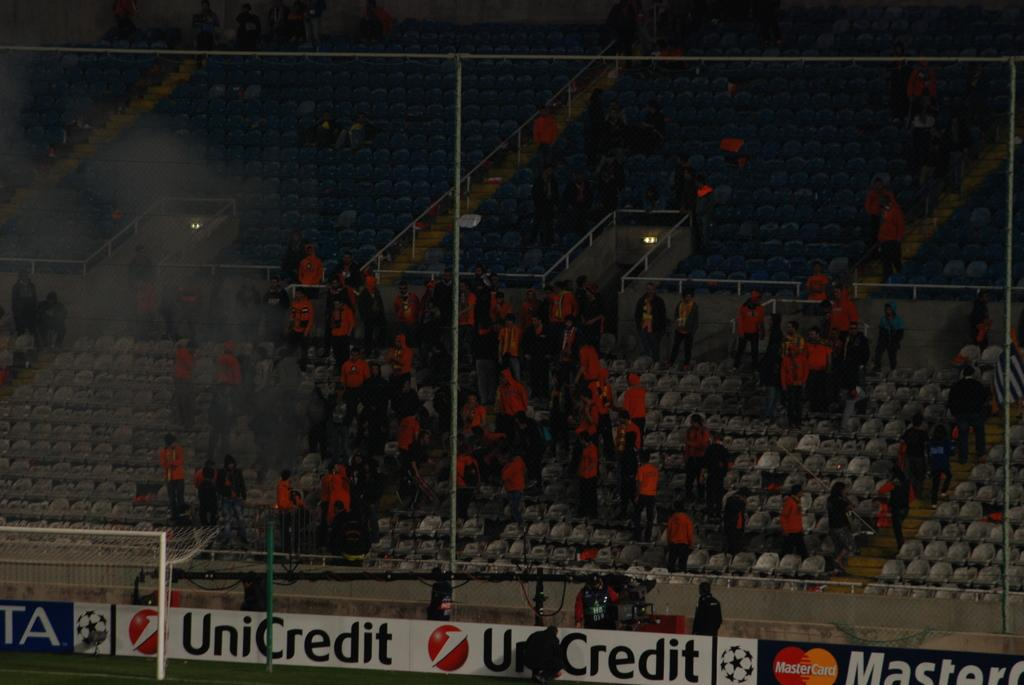<image>
Create a compact narrative representing the image presented. A banner for UniCredit is displayed in front of the bleachers. 